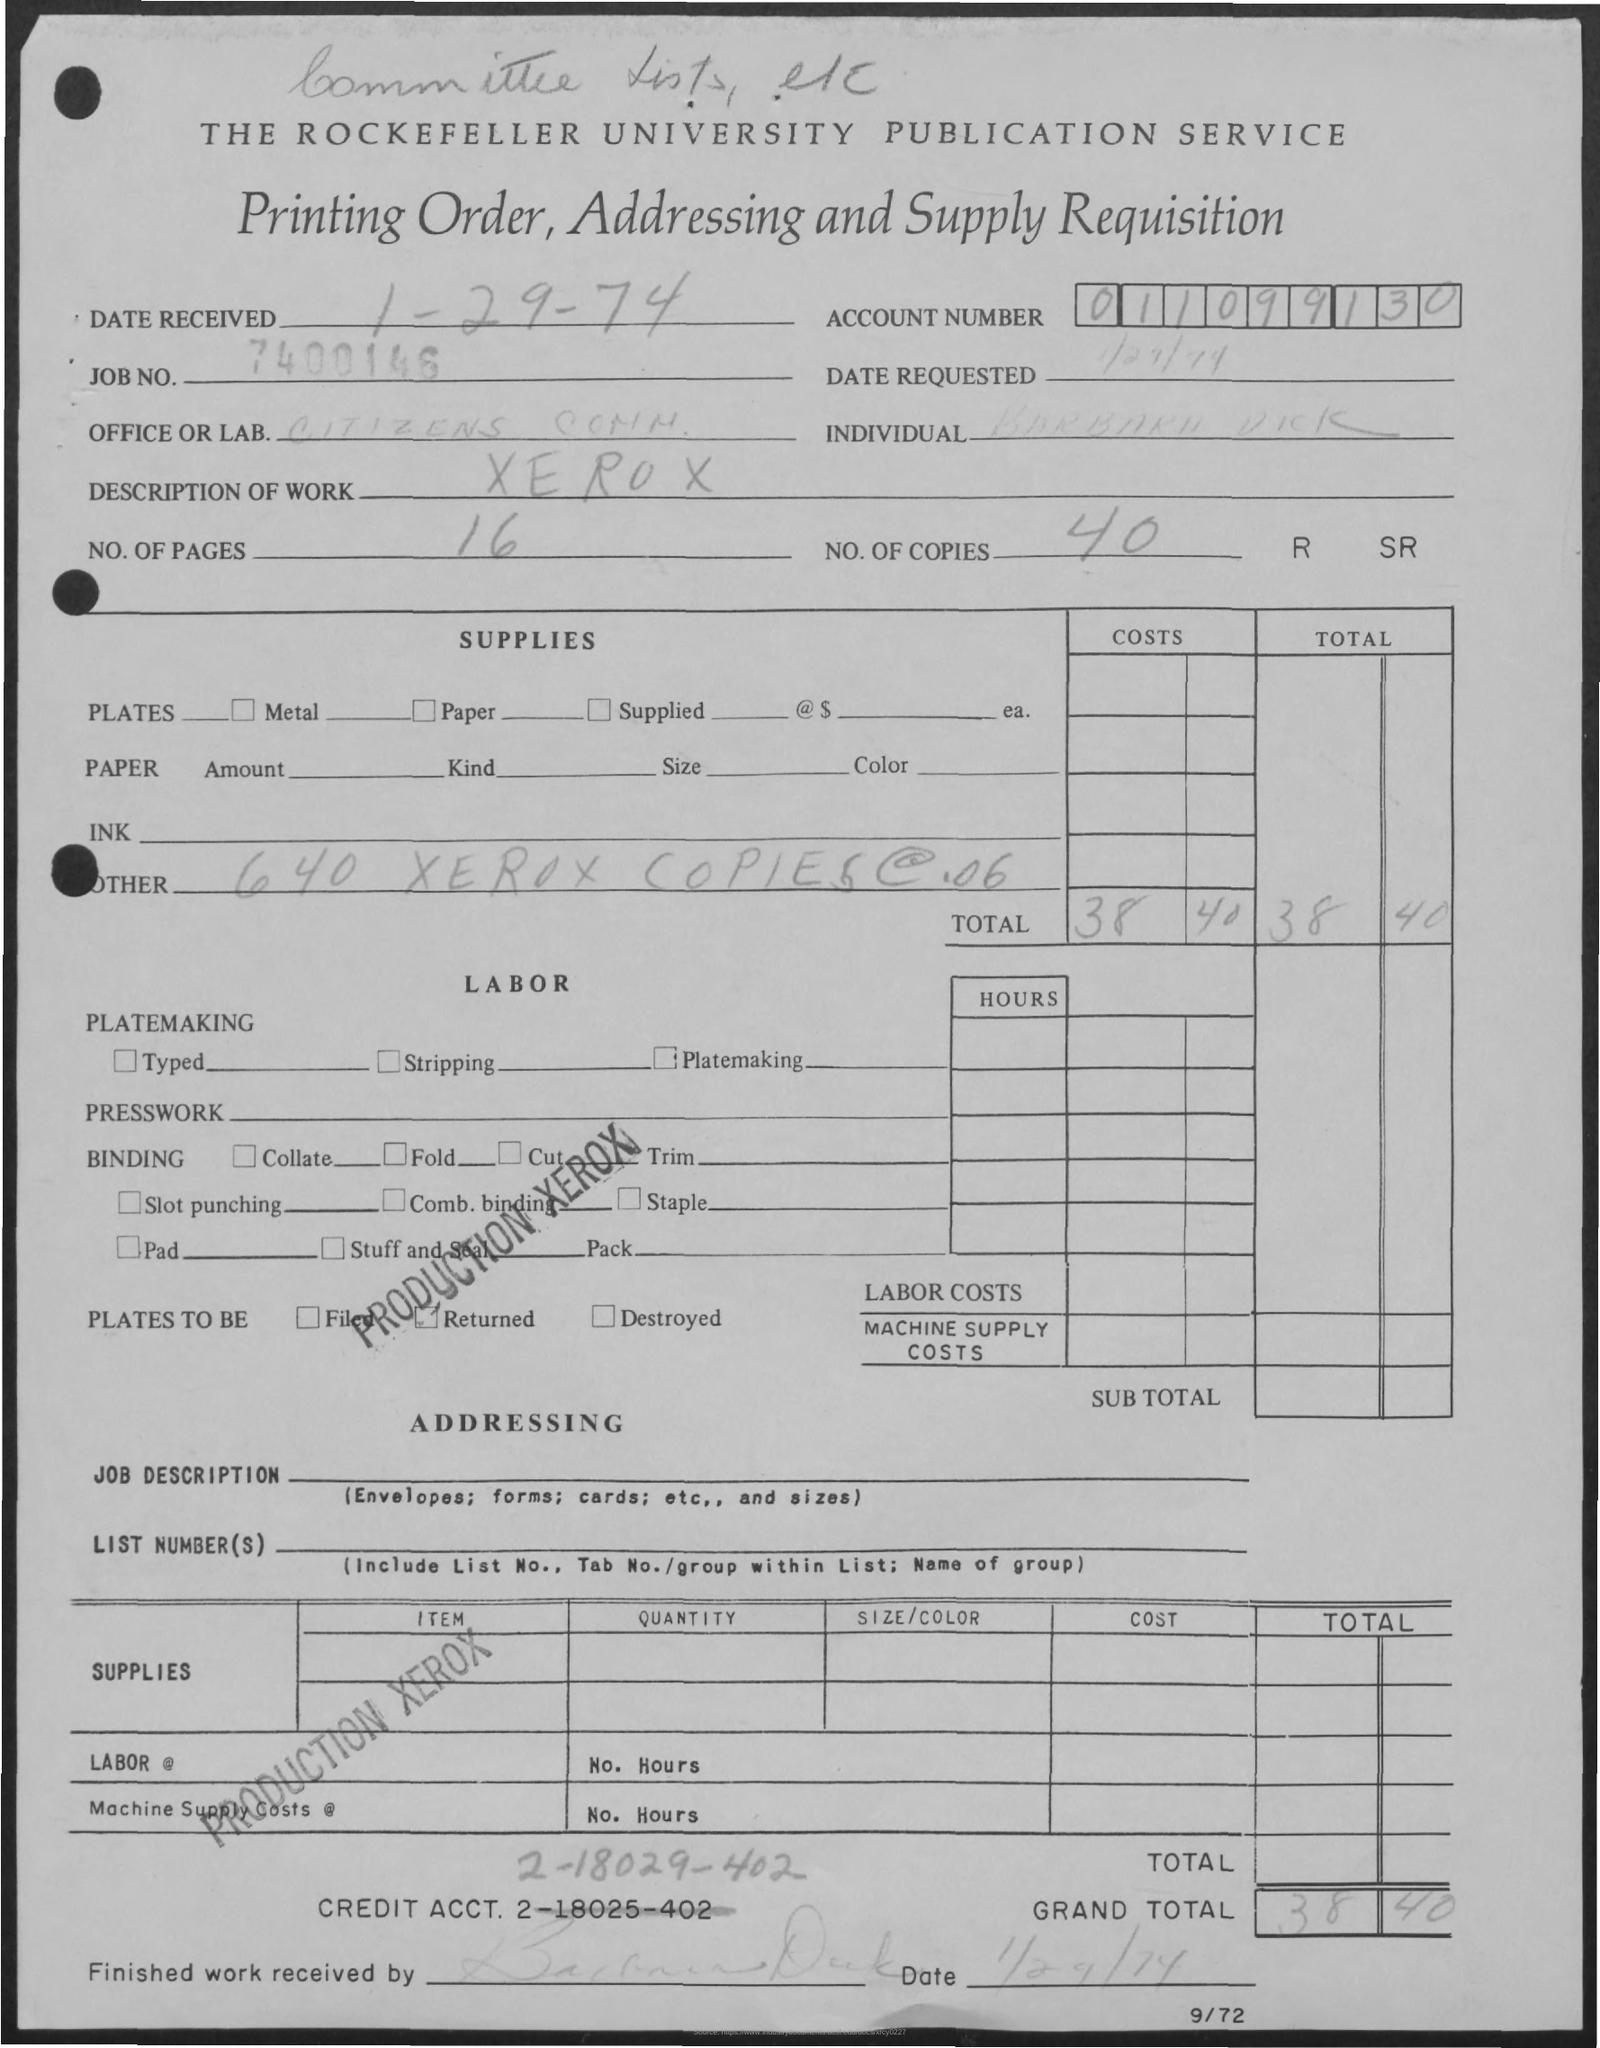What is the Date Received?
Offer a terse response. 1-29-74. What is the Job No.?
Your answer should be very brief. 7400146. What is the Account Number?
Your answer should be compact. 011099130. What is the Office or Lab?
Your answer should be very brief. Citizen's Comm. What is the Description of Work?
Your response must be concise. Xerox. What are the No. of Pages?
Provide a short and direct response. 16. What are the No. of Copies?
Give a very brief answer. 40. What is the Grand Total?
Provide a short and direct response. 38 40. What is the Credit Acct.?
Make the answer very short. 2-18029-402. 